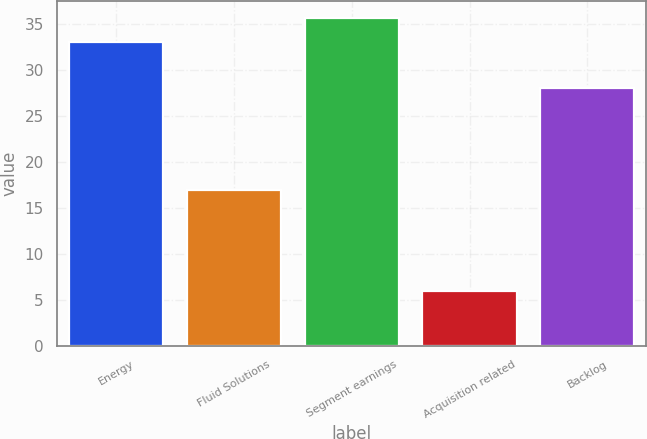Convert chart. <chart><loc_0><loc_0><loc_500><loc_500><bar_chart><fcel>Energy<fcel>Fluid Solutions<fcel>Segment earnings<fcel>Acquisition related<fcel>Backlog<nl><fcel>33<fcel>17<fcel>35.7<fcel>6<fcel>28<nl></chart> 